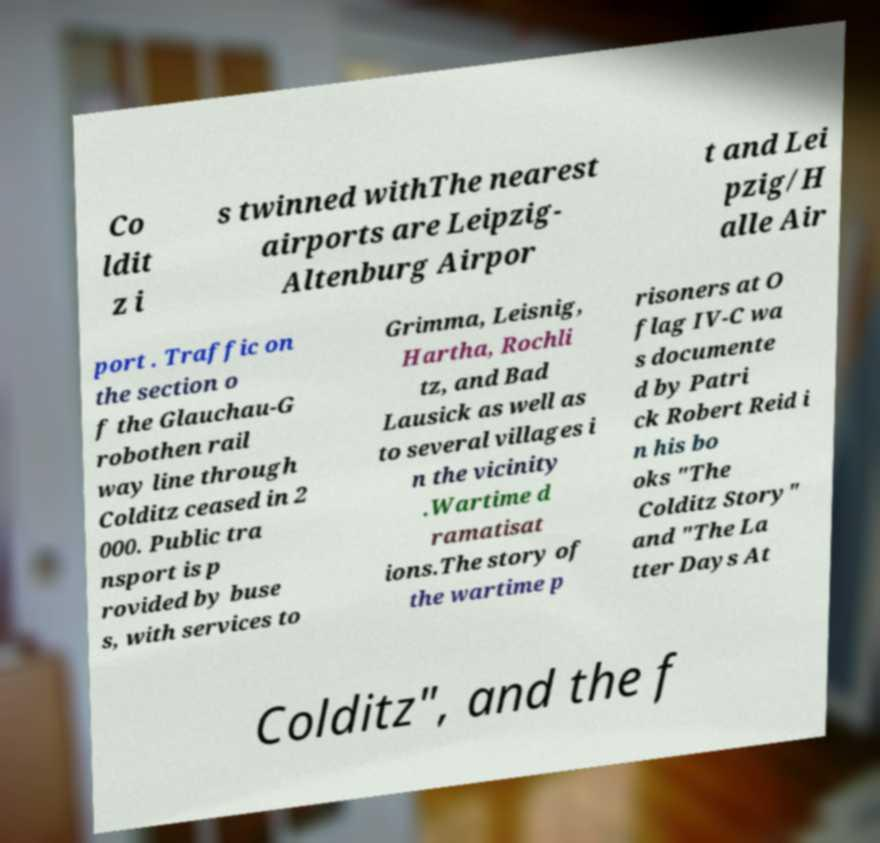There's text embedded in this image that I need extracted. Can you transcribe it verbatim? Co ldit z i s twinned withThe nearest airports are Leipzig- Altenburg Airpor t and Lei pzig/H alle Air port . Traffic on the section o f the Glauchau-G robothen rail way line through Colditz ceased in 2 000. Public tra nsport is p rovided by buse s, with services to Grimma, Leisnig, Hartha, Rochli tz, and Bad Lausick as well as to several villages i n the vicinity .Wartime d ramatisat ions.The story of the wartime p risoners at O flag IV-C wa s documente d by Patri ck Robert Reid i n his bo oks "The Colditz Story" and "The La tter Days At Colditz", and the f 